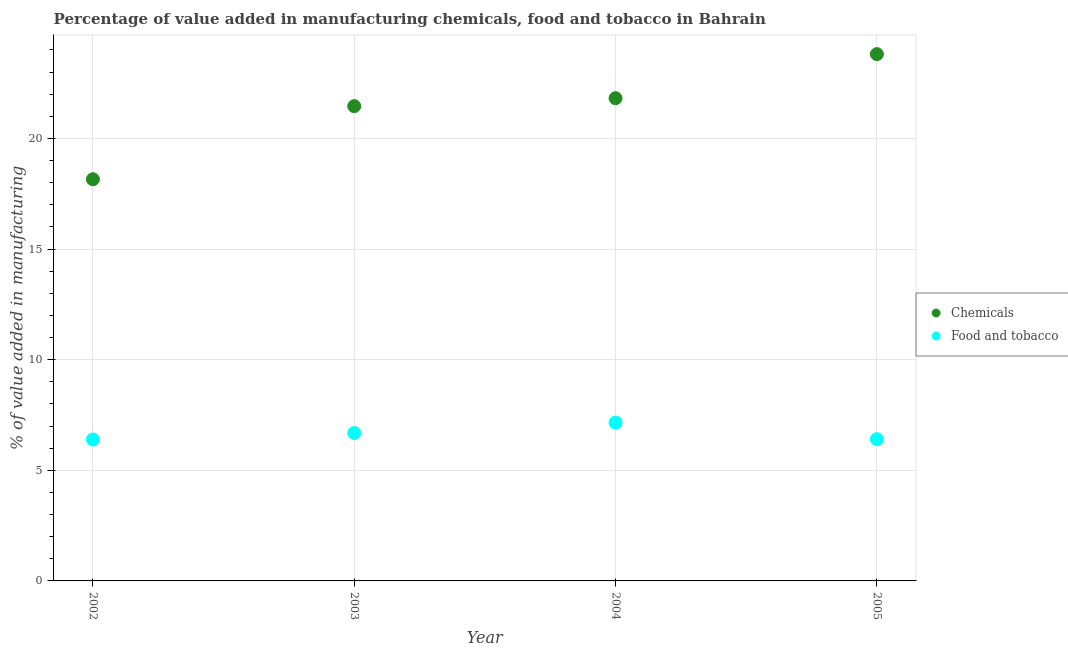How many different coloured dotlines are there?
Provide a succinct answer. 2. Is the number of dotlines equal to the number of legend labels?
Offer a very short reply. Yes. What is the value added by  manufacturing chemicals in 2005?
Your answer should be compact. 23.81. Across all years, what is the maximum value added by manufacturing food and tobacco?
Offer a very short reply. 7.16. Across all years, what is the minimum value added by manufacturing food and tobacco?
Keep it short and to the point. 6.39. What is the total value added by manufacturing food and tobacco in the graph?
Your answer should be very brief. 26.63. What is the difference between the value added by manufacturing food and tobacco in 2002 and that in 2004?
Your answer should be very brief. -0.77. What is the difference between the value added by  manufacturing chemicals in 2002 and the value added by manufacturing food and tobacco in 2005?
Keep it short and to the point. 11.75. What is the average value added by  manufacturing chemicals per year?
Provide a short and direct response. 21.31. In the year 2003, what is the difference between the value added by  manufacturing chemicals and value added by manufacturing food and tobacco?
Keep it short and to the point. 14.77. In how many years, is the value added by manufacturing food and tobacco greater than 1 %?
Provide a succinct answer. 4. What is the ratio of the value added by manufacturing food and tobacco in 2004 to that in 2005?
Your answer should be very brief. 1.12. Is the value added by  manufacturing chemicals in 2002 less than that in 2003?
Provide a succinct answer. Yes. What is the difference between the highest and the second highest value added by manufacturing food and tobacco?
Keep it short and to the point. 0.47. What is the difference between the highest and the lowest value added by manufacturing food and tobacco?
Your answer should be very brief. 0.77. In how many years, is the value added by  manufacturing chemicals greater than the average value added by  manufacturing chemicals taken over all years?
Give a very brief answer. 3. Is the sum of the value added by manufacturing food and tobacco in 2003 and 2004 greater than the maximum value added by  manufacturing chemicals across all years?
Provide a short and direct response. No. Does the value added by manufacturing food and tobacco monotonically increase over the years?
Give a very brief answer. No. Does the graph contain any zero values?
Provide a short and direct response. No. Where does the legend appear in the graph?
Give a very brief answer. Center right. What is the title of the graph?
Ensure brevity in your answer.  Percentage of value added in manufacturing chemicals, food and tobacco in Bahrain. What is the label or title of the Y-axis?
Give a very brief answer. % of value added in manufacturing. What is the % of value added in manufacturing of Chemicals in 2002?
Keep it short and to the point. 18.15. What is the % of value added in manufacturing in Food and tobacco in 2002?
Your response must be concise. 6.39. What is the % of value added in manufacturing of Chemicals in 2003?
Provide a succinct answer. 21.46. What is the % of value added in manufacturing of Food and tobacco in 2003?
Give a very brief answer. 6.68. What is the % of value added in manufacturing of Chemicals in 2004?
Ensure brevity in your answer.  21.82. What is the % of value added in manufacturing of Food and tobacco in 2004?
Keep it short and to the point. 7.16. What is the % of value added in manufacturing of Chemicals in 2005?
Provide a succinct answer. 23.81. What is the % of value added in manufacturing in Food and tobacco in 2005?
Your answer should be very brief. 6.41. Across all years, what is the maximum % of value added in manufacturing of Chemicals?
Provide a succinct answer. 23.81. Across all years, what is the maximum % of value added in manufacturing of Food and tobacco?
Your answer should be very brief. 7.16. Across all years, what is the minimum % of value added in manufacturing in Chemicals?
Offer a very short reply. 18.15. Across all years, what is the minimum % of value added in manufacturing of Food and tobacco?
Your answer should be very brief. 6.39. What is the total % of value added in manufacturing in Chemicals in the graph?
Give a very brief answer. 85.23. What is the total % of value added in manufacturing of Food and tobacco in the graph?
Your answer should be very brief. 26.63. What is the difference between the % of value added in manufacturing of Chemicals in 2002 and that in 2003?
Make the answer very short. -3.3. What is the difference between the % of value added in manufacturing of Food and tobacco in 2002 and that in 2003?
Make the answer very short. -0.29. What is the difference between the % of value added in manufacturing in Chemicals in 2002 and that in 2004?
Provide a short and direct response. -3.66. What is the difference between the % of value added in manufacturing in Food and tobacco in 2002 and that in 2004?
Provide a succinct answer. -0.77. What is the difference between the % of value added in manufacturing in Chemicals in 2002 and that in 2005?
Make the answer very short. -5.65. What is the difference between the % of value added in manufacturing in Food and tobacco in 2002 and that in 2005?
Your response must be concise. -0.01. What is the difference between the % of value added in manufacturing in Chemicals in 2003 and that in 2004?
Provide a succinct answer. -0.36. What is the difference between the % of value added in manufacturing in Food and tobacco in 2003 and that in 2004?
Keep it short and to the point. -0.47. What is the difference between the % of value added in manufacturing in Chemicals in 2003 and that in 2005?
Provide a short and direct response. -2.35. What is the difference between the % of value added in manufacturing of Food and tobacco in 2003 and that in 2005?
Provide a short and direct response. 0.28. What is the difference between the % of value added in manufacturing in Chemicals in 2004 and that in 2005?
Your answer should be compact. -1.99. What is the difference between the % of value added in manufacturing in Food and tobacco in 2004 and that in 2005?
Give a very brief answer. 0.75. What is the difference between the % of value added in manufacturing of Chemicals in 2002 and the % of value added in manufacturing of Food and tobacco in 2003?
Offer a very short reply. 11.47. What is the difference between the % of value added in manufacturing in Chemicals in 2002 and the % of value added in manufacturing in Food and tobacco in 2004?
Offer a very short reply. 11. What is the difference between the % of value added in manufacturing in Chemicals in 2002 and the % of value added in manufacturing in Food and tobacco in 2005?
Your answer should be compact. 11.75. What is the difference between the % of value added in manufacturing of Chemicals in 2003 and the % of value added in manufacturing of Food and tobacco in 2004?
Keep it short and to the point. 14.3. What is the difference between the % of value added in manufacturing of Chemicals in 2003 and the % of value added in manufacturing of Food and tobacco in 2005?
Your answer should be compact. 15.05. What is the difference between the % of value added in manufacturing in Chemicals in 2004 and the % of value added in manufacturing in Food and tobacco in 2005?
Your answer should be very brief. 15.41. What is the average % of value added in manufacturing of Chemicals per year?
Keep it short and to the point. 21.31. What is the average % of value added in manufacturing in Food and tobacco per year?
Offer a terse response. 6.66. In the year 2002, what is the difference between the % of value added in manufacturing of Chemicals and % of value added in manufacturing of Food and tobacco?
Make the answer very short. 11.76. In the year 2003, what is the difference between the % of value added in manufacturing in Chemicals and % of value added in manufacturing in Food and tobacco?
Keep it short and to the point. 14.77. In the year 2004, what is the difference between the % of value added in manufacturing in Chemicals and % of value added in manufacturing in Food and tobacco?
Your response must be concise. 14.66. In the year 2005, what is the difference between the % of value added in manufacturing in Chemicals and % of value added in manufacturing in Food and tobacco?
Your response must be concise. 17.4. What is the ratio of the % of value added in manufacturing in Chemicals in 2002 to that in 2003?
Your answer should be compact. 0.85. What is the ratio of the % of value added in manufacturing of Food and tobacco in 2002 to that in 2003?
Offer a very short reply. 0.96. What is the ratio of the % of value added in manufacturing of Chemicals in 2002 to that in 2004?
Your answer should be very brief. 0.83. What is the ratio of the % of value added in manufacturing in Food and tobacco in 2002 to that in 2004?
Provide a succinct answer. 0.89. What is the ratio of the % of value added in manufacturing in Chemicals in 2002 to that in 2005?
Your answer should be very brief. 0.76. What is the ratio of the % of value added in manufacturing in Chemicals in 2003 to that in 2004?
Provide a short and direct response. 0.98. What is the ratio of the % of value added in manufacturing in Food and tobacco in 2003 to that in 2004?
Your answer should be compact. 0.93. What is the ratio of the % of value added in manufacturing of Chemicals in 2003 to that in 2005?
Your answer should be compact. 0.9. What is the ratio of the % of value added in manufacturing of Food and tobacco in 2003 to that in 2005?
Offer a very short reply. 1.04. What is the ratio of the % of value added in manufacturing in Chemicals in 2004 to that in 2005?
Make the answer very short. 0.92. What is the ratio of the % of value added in manufacturing in Food and tobacco in 2004 to that in 2005?
Provide a succinct answer. 1.12. What is the difference between the highest and the second highest % of value added in manufacturing of Chemicals?
Your answer should be very brief. 1.99. What is the difference between the highest and the second highest % of value added in manufacturing of Food and tobacco?
Keep it short and to the point. 0.47. What is the difference between the highest and the lowest % of value added in manufacturing in Chemicals?
Make the answer very short. 5.65. What is the difference between the highest and the lowest % of value added in manufacturing in Food and tobacco?
Make the answer very short. 0.77. 